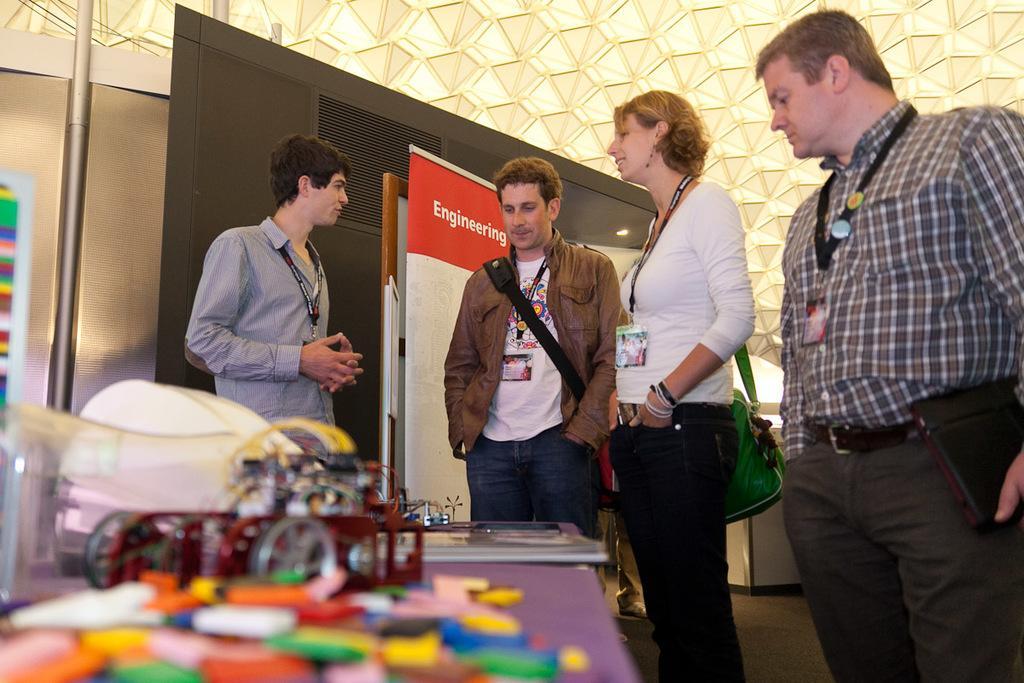In one or two sentences, can you explain what this image depicts? In this image we can see few people standing in a room, there is a table with few objects in front of them, there is a poster and an object behind the persons and there is a metal pole on the left side and a wall in the background. 